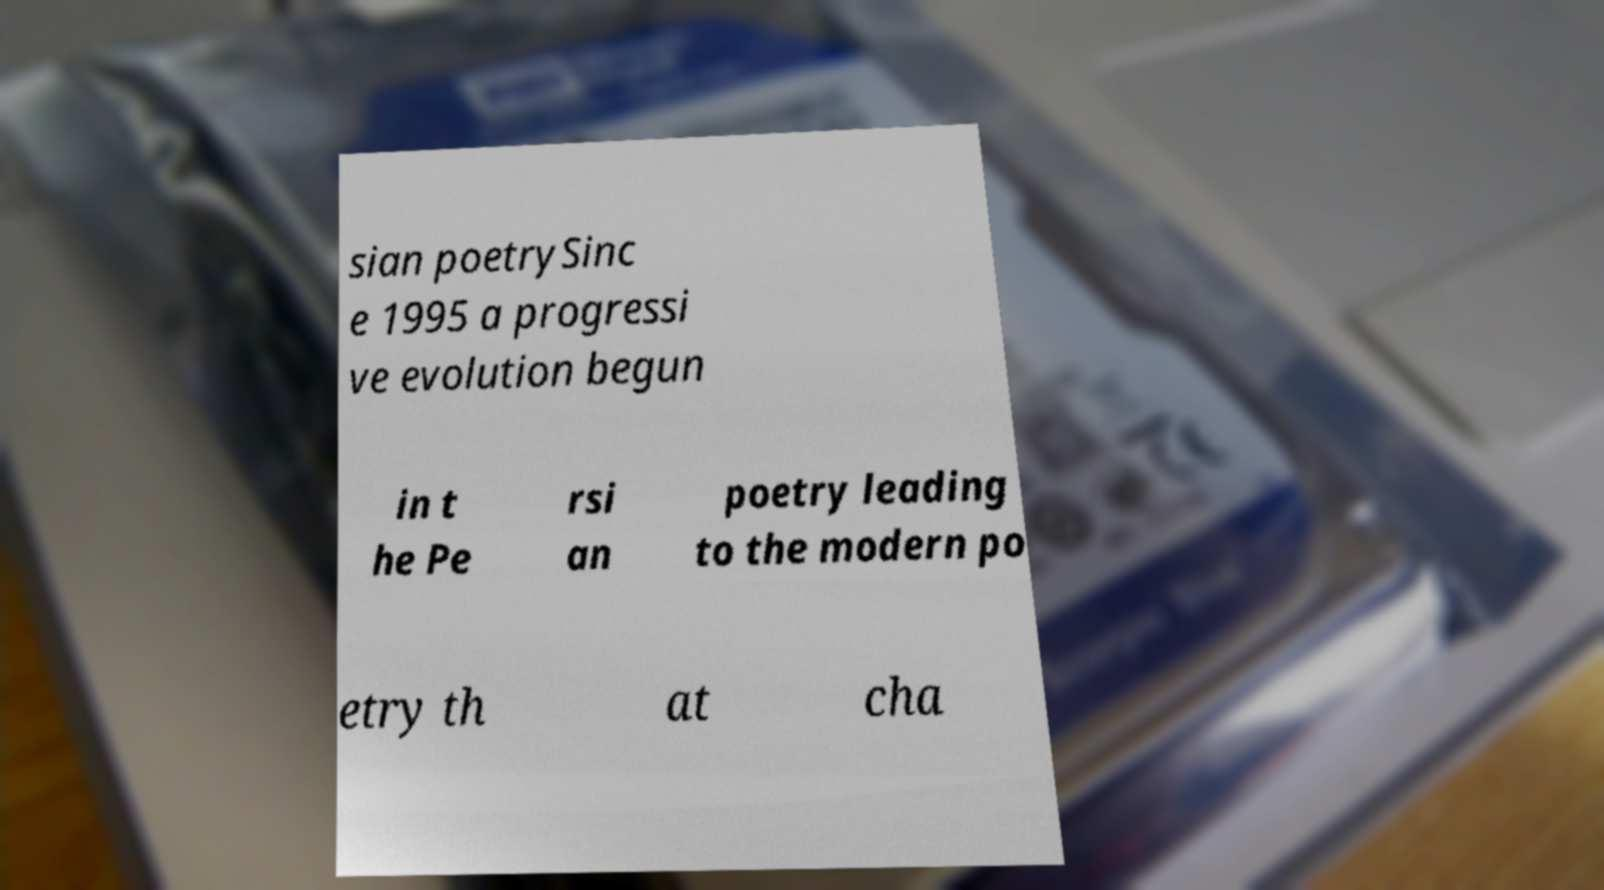Could you extract and type out the text from this image? sian poetrySinc e 1995 a progressi ve evolution begun in t he Pe rsi an poetry leading to the modern po etry th at cha 